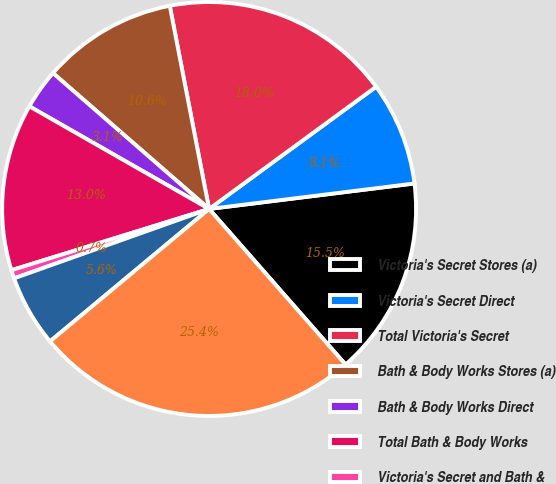<chart> <loc_0><loc_0><loc_500><loc_500><pie_chart><fcel>Victoria's Secret Stores (a)<fcel>Victoria's Secret Direct<fcel>Total Victoria's Secret<fcel>Bath & Body Works Stores (a)<fcel>Bath & Body Works Direct<fcel>Total Bath & Body Works<fcel>Victoria's Secret and Bath &<fcel>Other (b)<fcel>Total Net Sales<nl><fcel>15.51%<fcel>8.09%<fcel>17.99%<fcel>10.56%<fcel>3.14%<fcel>13.04%<fcel>0.66%<fcel>5.61%<fcel>25.41%<nl></chart> 